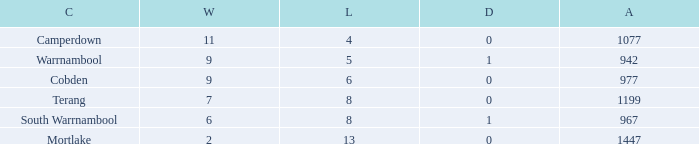How many draws did Mortlake have when the losses were more than 5? 1.0. 